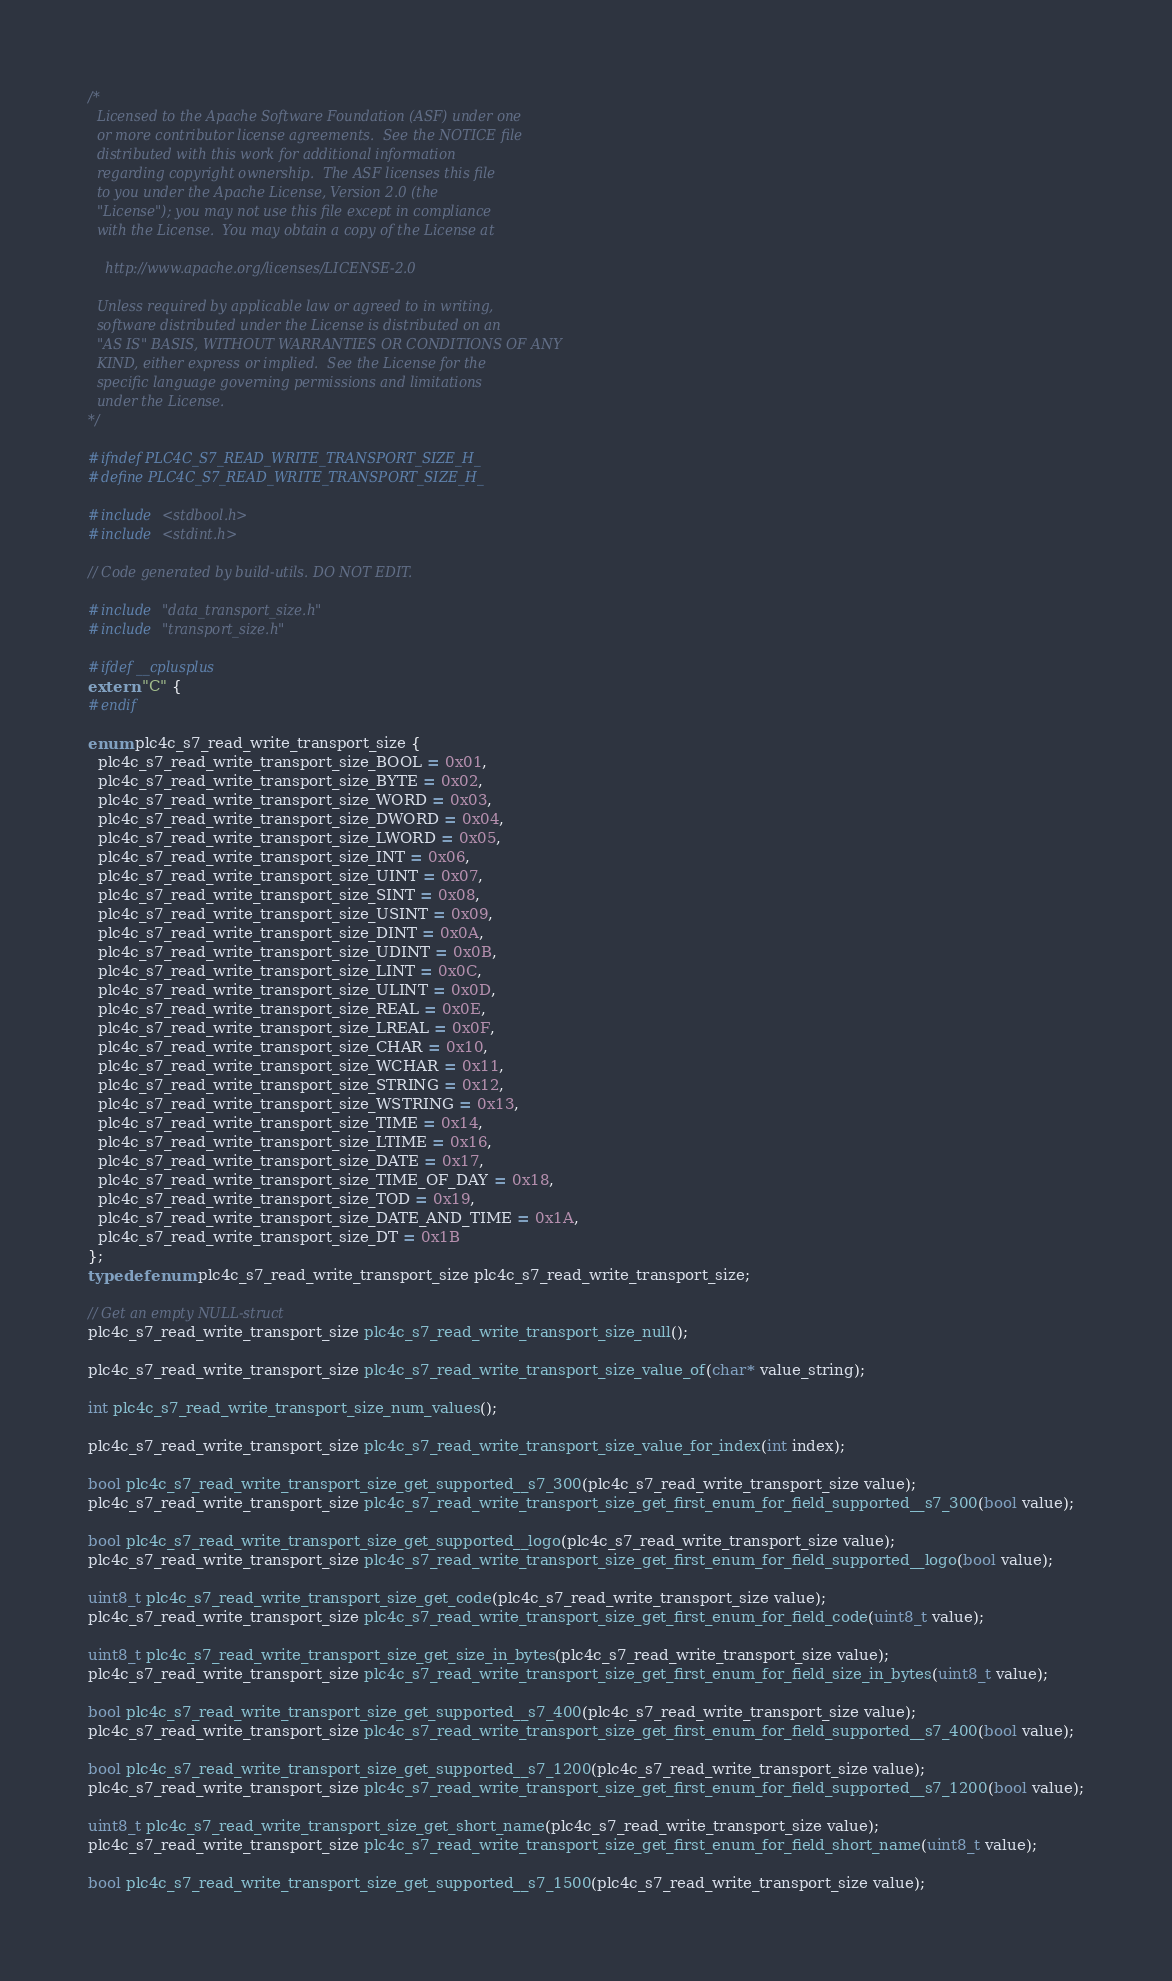Convert code to text. <code><loc_0><loc_0><loc_500><loc_500><_C_>/*
  Licensed to the Apache Software Foundation (ASF) under one
  or more contributor license agreements.  See the NOTICE file
  distributed with this work for additional information
  regarding copyright ownership.  The ASF licenses this file
  to you under the Apache License, Version 2.0 (the
  "License"); you may not use this file except in compliance
  with the License.  You may obtain a copy of the License at

    http://www.apache.org/licenses/LICENSE-2.0

  Unless required by applicable law or agreed to in writing,
  software distributed under the License is distributed on an
  "AS IS" BASIS, WITHOUT WARRANTIES OR CONDITIONS OF ANY
  KIND, either express or implied.  See the License for the
  specific language governing permissions and limitations
  under the License.
*/

#ifndef PLC4C_S7_READ_WRITE_TRANSPORT_SIZE_H_
#define PLC4C_S7_READ_WRITE_TRANSPORT_SIZE_H_

#include <stdbool.h>
#include <stdint.h>

// Code generated by build-utils. DO NOT EDIT.

#include "data_transport_size.h"
#include "transport_size.h"

#ifdef __cplusplus
extern "C" {
#endif

enum plc4c_s7_read_write_transport_size {
  plc4c_s7_read_write_transport_size_BOOL = 0x01,
  plc4c_s7_read_write_transport_size_BYTE = 0x02,
  plc4c_s7_read_write_transport_size_WORD = 0x03,
  plc4c_s7_read_write_transport_size_DWORD = 0x04,
  plc4c_s7_read_write_transport_size_LWORD = 0x05,
  plc4c_s7_read_write_transport_size_INT = 0x06,
  plc4c_s7_read_write_transport_size_UINT = 0x07,
  plc4c_s7_read_write_transport_size_SINT = 0x08,
  plc4c_s7_read_write_transport_size_USINT = 0x09,
  plc4c_s7_read_write_transport_size_DINT = 0x0A,
  plc4c_s7_read_write_transport_size_UDINT = 0x0B,
  plc4c_s7_read_write_transport_size_LINT = 0x0C,
  plc4c_s7_read_write_transport_size_ULINT = 0x0D,
  plc4c_s7_read_write_transport_size_REAL = 0x0E,
  plc4c_s7_read_write_transport_size_LREAL = 0x0F,
  plc4c_s7_read_write_transport_size_CHAR = 0x10,
  plc4c_s7_read_write_transport_size_WCHAR = 0x11,
  plc4c_s7_read_write_transport_size_STRING = 0x12,
  plc4c_s7_read_write_transport_size_WSTRING = 0x13,
  plc4c_s7_read_write_transport_size_TIME = 0x14,
  plc4c_s7_read_write_transport_size_LTIME = 0x16,
  plc4c_s7_read_write_transport_size_DATE = 0x17,
  plc4c_s7_read_write_transport_size_TIME_OF_DAY = 0x18,
  plc4c_s7_read_write_transport_size_TOD = 0x19,
  plc4c_s7_read_write_transport_size_DATE_AND_TIME = 0x1A,
  plc4c_s7_read_write_transport_size_DT = 0x1B
};
typedef enum plc4c_s7_read_write_transport_size plc4c_s7_read_write_transport_size;

// Get an empty NULL-struct
plc4c_s7_read_write_transport_size plc4c_s7_read_write_transport_size_null();

plc4c_s7_read_write_transport_size plc4c_s7_read_write_transport_size_value_of(char* value_string);

int plc4c_s7_read_write_transport_size_num_values();

plc4c_s7_read_write_transport_size plc4c_s7_read_write_transport_size_value_for_index(int index);

bool plc4c_s7_read_write_transport_size_get_supported__s7_300(plc4c_s7_read_write_transport_size value);
plc4c_s7_read_write_transport_size plc4c_s7_read_write_transport_size_get_first_enum_for_field_supported__s7_300(bool value);

bool plc4c_s7_read_write_transport_size_get_supported__logo(plc4c_s7_read_write_transport_size value);
plc4c_s7_read_write_transport_size plc4c_s7_read_write_transport_size_get_first_enum_for_field_supported__logo(bool value);

uint8_t plc4c_s7_read_write_transport_size_get_code(plc4c_s7_read_write_transport_size value);
plc4c_s7_read_write_transport_size plc4c_s7_read_write_transport_size_get_first_enum_for_field_code(uint8_t value);

uint8_t plc4c_s7_read_write_transport_size_get_size_in_bytes(plc4c_s7_read_write_transport_size value);
plc4c_s7_read_write_transport_size plc4c_s7_read_write_transport_size_get_first_enum_for_field_size_in_bytes(uint8_t value);

bool plc4c_s7_read_write_transport_size_get_supported__s7_400(plc4c_s7_read_write_transport_size value);
plc4c_s7_read_write_transport_size plc4c_s7_read_write_transport_size_get_first_enum_for_field_supported__s7_400(bool value);

bool plc4c_s7_read_write_transport_size_get_supported__s7_1200(plc4c_s7_read_write_transport_size value);
plc4c_s7_read_write_transport_size plc4c_s7_read_write_transport_size_get_first_enum_for_field_supported__s7_1200(bool value);

uint8_t plc4c_s7_read_write_transport_size_get_short_name(plc4c_s7_read_write_transport_size value);
plc4c_s7_read_write_transport_size plc4c_s7_read_write_transport_size_get_first_enum_for_field_short_name(uint8_t value);

bool plc4c_s7_read_write_transport_size_get_supported__s7_1500(plc4c_s7_read_write_transport_size value);</code> 